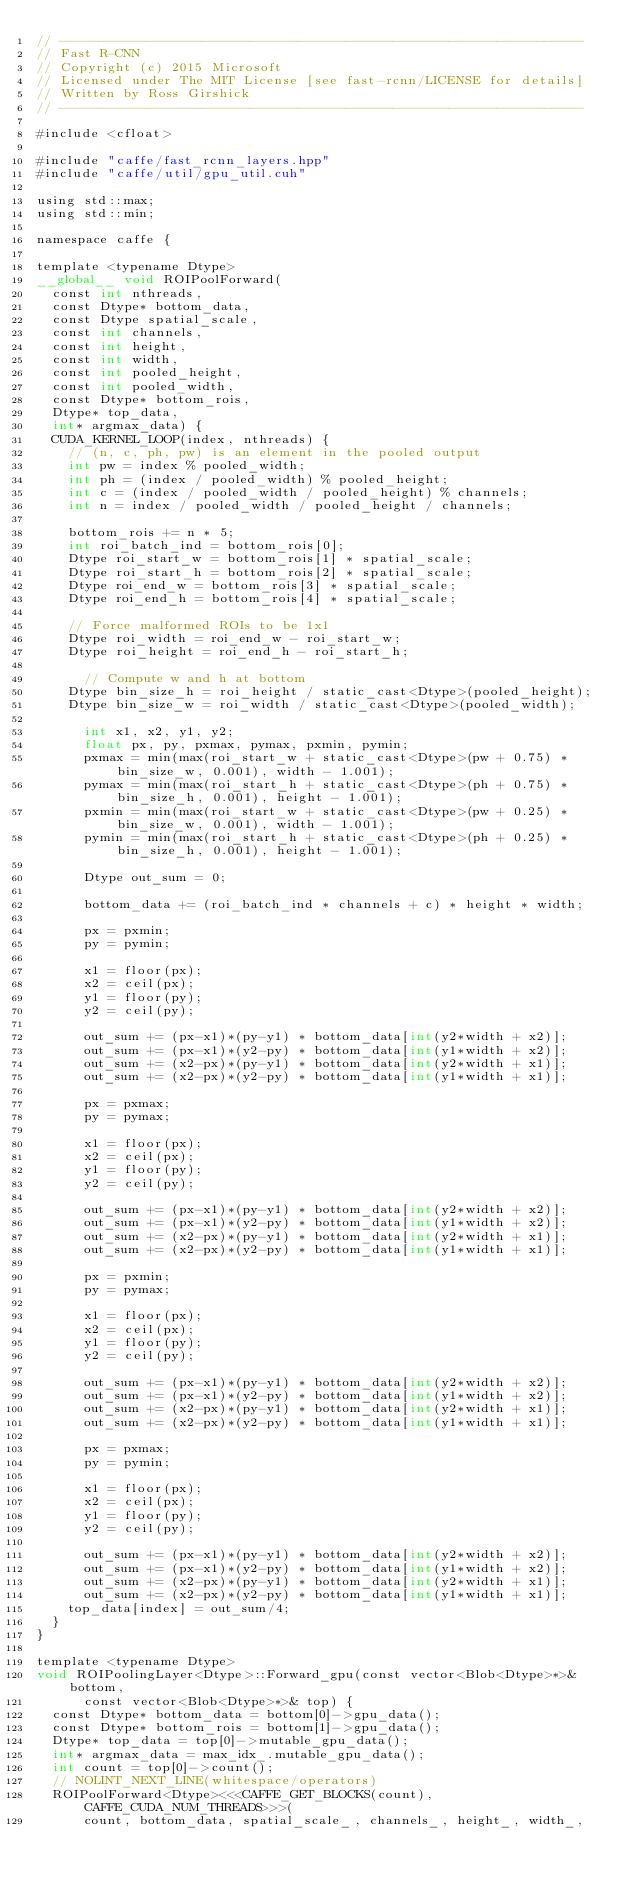Convert code to text. <code><loc_0><loc_0><loc_500><loc_500><_Cuda_>// ------------------------------------------------------------------
// Fast R-CNN
// Copyright (c) 2015 Microsoft
// Licensed under The MIT License [see fast-rcnn/LICENSE for details]
// Written by Ross Girshick
// ------------------------------------------------------------------

#include <cfloat>

#include "caffe/fast_rcnn_layers.hpp"
#include "caffe/util/gpu_util.cuh"

using std::max;
using std::min;

namespace caffe {

template <typename Dtype>
__global__ void ROIPoolForward(
  const int nthreads, 
  const Dtype* bottom_data,
  const Dtype spatial_scale, 
  const int channels, 
  const int height,
  const int width, 
  const int pooled_height, 
  const int pooled_width,
  const Dtype* bottom_rois, 
  Dtype* top_data, 
  int* argmax_data) {
  CUDA_KERNEL_LOOP(index, nthreads) {
    // (n, c, ph, pw) is an element in the pooled output
    int pw = index % pooled_width;
    int ph = (index / pooled_width) % pooled_height;
    int c = (index / pooled_width / pooled_height) % channels;
    int n = index / pooled_width / pooled_height / channels;

    bottom_rois += n * 5;
    int roi_batch_ind = bottom_rois[0];
    Dtype roi_start_w = bottom_rois[1] * spatial_scale;
    Dtype roi_start_h = bottom_rois[2] * spatial_scale;
    Dtype roi_end_w = bottom_rois[3] * spatial_scale;
    Dtype roi_end_h = bottom_rois[4] * spatial_scale;

    // Force malformed ROIs to be 1x1
    Dtype roi_width = roi_end_w - roi_start_w;
    Dtype roi_height = roi_end_h - roi_start_h;

      // Compute w and h at bottom
    Dtype bin_size_h = roi_height / static_cast<Dtype>(pooled_height);
    Dtype bin_size_w = roi_width / static_cast<Dtype>(pooled_width);

      int x1, x2, y1, y2;
      float px, py, pxmax, pymax, pxmin, pymin;
      pxmax = min(max(roi_start_w + static_cast<Dtype>(pw + 0.75) * bin_size_w, 0.001), width - 1.001);
      pymax = min(max(roi_start_h + static_cast<Dtype>(ph + 0.75) * bin_size_h, 0.001), height - 1.001);
      pxmin = min(max(roi_start_w + static_cast<Dtype>(pw + 0.25) * bin_size_w, 0.001), width - 1.001);
      pymin = min(max(roi_start_h + static_cast<Dtype>(ph + 0.25) * bin_size_h, 0.001), height - 1.001);

      Dtype out_sum = 0;

      bottom_data += (roi_batch_ind * channels + c) * height * width;

      px = pxmin;
      py = pymin;

      x1 = floor(px);
      x2 = ceil(px);
      y1 = floor(py);
      y2 = ceil(py);

      out_sum += (px-x1)*(py-y1) * bottom_data[int(y2*width + x2)];
      out_sum += (px-x1)*(y2-py) * bottom_data[int(y1*width + x2)];
      out_sum += (x2-px)*(py-y1) * bottom_data[int(y2*width + x1)];
      out_sum += (x2-px)*(y2-py) * bottom_data[int(y1*width + x1)];

      px = pxmax;
      py = pymax;

      x1 = floor(px);
      x2 = ceil(px);
      y1 = floor(py);
      y2 = ceil(py);

      out_sum += (px-x1)*(py-y1) * bottom_data[int(y2*width + x2)];
      out_sum += (px-x1)*(y2-py) * bottom_data[int(y1*width + x2)];
      out_sum += (x2-px)*(py-y1) * bottom_data[int(y2*width + x1)];
      out_sum += (x2-px)*(y2-py) * bottom_data[int(y1*width + x1)];

      px = pxmin;
      py = pymax;

      x1 = floor(px);
      x2 = ceil(px);
      y1 = floor(py);
      y2 = ceil(py);

      out_sum += (px-x1)*(py-y1) * bottom_data[int(y2*width + x2)];
      out_sum += (px-x1)*(y2-py) * bottom_data[int(y1*width + x2)];
      out_sum += (x2-px)*(py-y1) * bottom_data[int(y2*width + x1)];
      out_sum += (x2-px)*(y2-py) * bottom_data[int(y1*width + x1)];

      px = pxmax;
      py = pymin;

      x1 = floor(px);
      x2 = ceil(px);
      y1 = floor(py);
      y2 = ceil(py);

      out_sum += (px-x1)*(py-y1) * bottom_data[int(y2*width + x2)];
      out_sum += (px-x1)*(y2-py) * bottom_data[int(y1*width + x2)];
      out_sum += (x2-px)*(py-y1) * bottom_data[int(y2*width + x1)];
      out_sum += (x2-px)*(y2-py) * bottom_data[int(y1*width + x1)];
    top_data[index] = out_sum/4;
  }
}

template <typename Dtype>
void ROIPoolingLayer<Dtype>::Forward_gpu(const vector<Blob<Dtype>*>& bottom,
      const vector<Blob<Dtype>*>& top) {
  const Dtype* bottom_data = bottom[0]->gpu_data();
  const Dtype* bottom_rois = bottom[1]->gpu_data();
  Dtype* top_data = top[0]->mutable_gpu_data();
  int* argmax_data = max_idx_.mutable_gpu_data();
  int count = top[0]->count();
  // NOLINT_NEXT_LINE(whitespace/operators)
  ROIPoolForward<Dtype><<<CAFFE_GET_BLOCKS(count), CAFFE_CUDA_NUM_THREADS>>>(
      count, bottom_data, spatial_scale_, channels_, height_, width_,</code> 